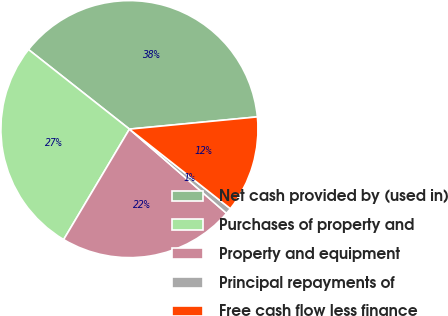<chart> <loc_0><loc_0><loc_500><loc_500><pie_chart><fcel>Net cash provided by (used in)<fcel>Purchases of property and<fcel>Property and equipment<fcel>Principal repayments of<fcel>Free cash flow less finance<nl><fcel>37.86%<fcel>27.08%<fcel>22.18%<fcel>0.75%<fcel>12.14%<nl></chart> 